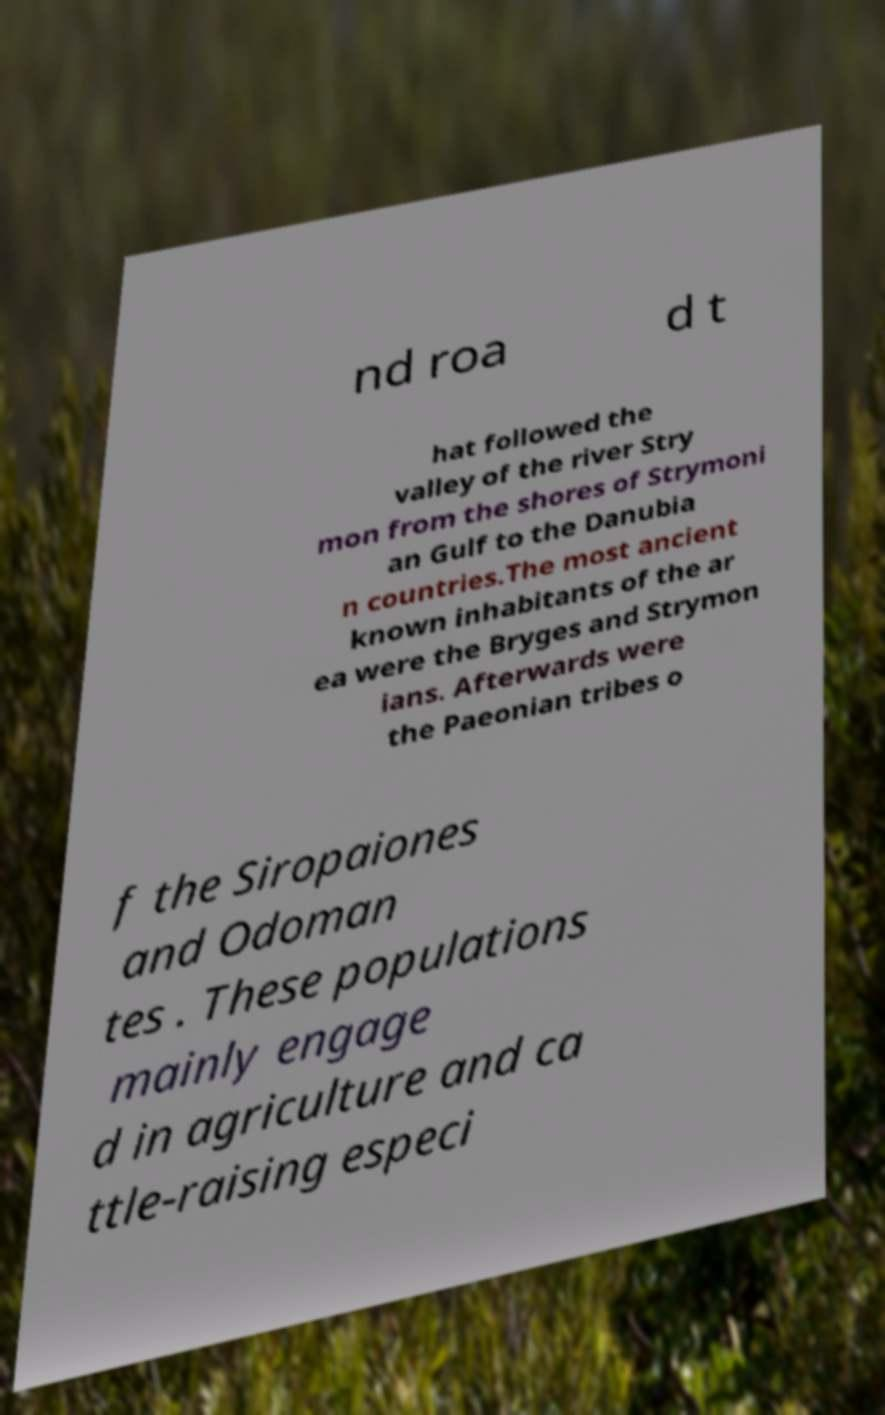Please identify and transcribe the text found in this image. nd roa d t hat followed the valley of the river Stry mon from the shores of Strymoni an Gulf to the Danubia n countries.The most ancient known inhabitants of the ar ea were the Bryges and Strymon ians. Afterwards were the Paeonian tribes o f the Siropaiones and Odoman tes . These populations mainly engage d in agriculture and ca ttle-raising especi 